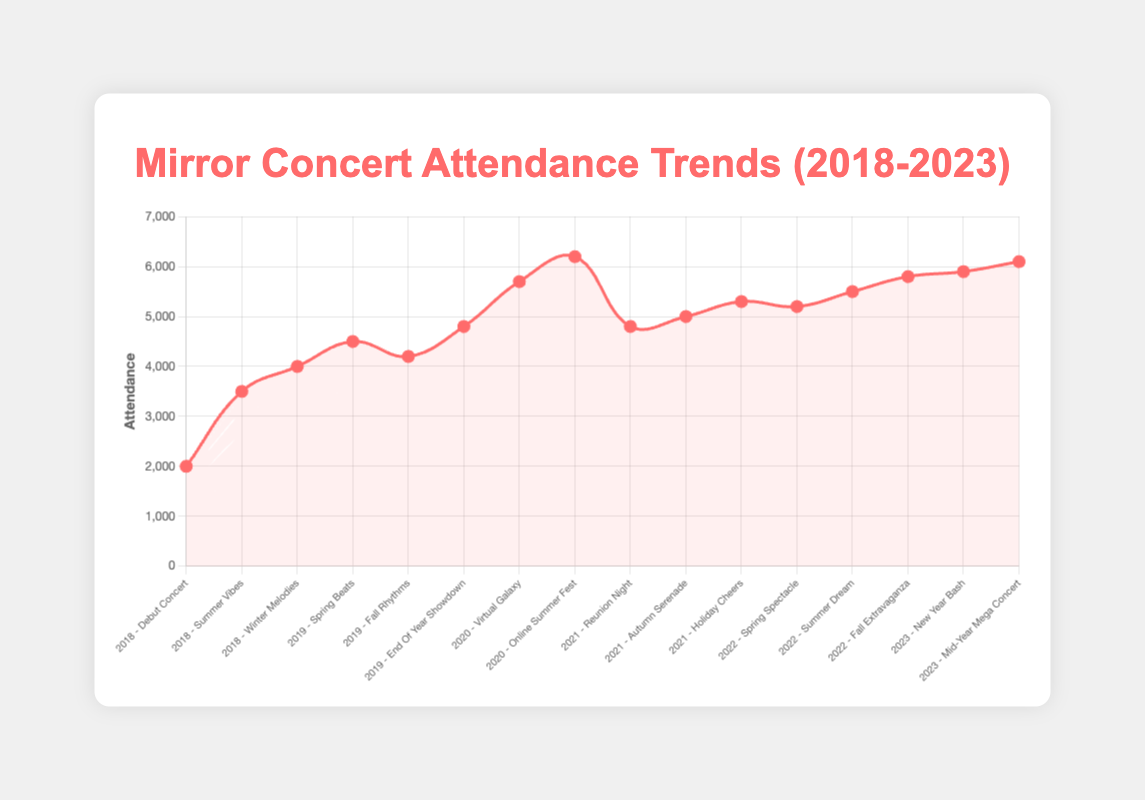What is the overall trend in Mirror's concert attendance from 2018 to 2023? Looking at the line plot, the general trend shows an increase in concert attendance over the years from 2018 to 2023. The attendance started at 2000 in 2018 and reached 6100 by the mid-year concert in 2023.
Answer: Increasing Which concert had the highest attendance over the entire period from 2018 to 2023? The concert with the highest attendance is the "Online Summer Fest" in 2020, with an attendance of 6200. This is evident from the peak point on the plot in the year 2020.
Answer: Online Summer Fest in 2020 How did the attendance of "End Of Year Showdown" in 2019 compare to "Reunion Night" in 2021? "End Of Year Showdown" in 2019 had an attendance of 4800, while "Reunion Night" in 2021 also had an attendance of 4800. Both concerts had the same attendance.
Answer: Equal What is the total concert attendance for the year 2021? The total attendance for 2021 is calculated by summing the attendance of all concerts in that year: 4800 (Reunion Night) + 5000 (Autumn Serenade) + 5300 (Holiday Cheers) = 15100.
Answer: 15100 How much did the attendance increase or decrease from "Debut Concert" in 2018 to "New Year Bash" in 2023? The attendance for "Debut Concert" in 2018 was 2000, and for "New Year Bash" in 2023 was 5900. The increase is calculated as 5900 - 2000 = 3900.
Answer: Increased by 3900 What is the average attendance of all concerts in 2020? The average attendance for 2020 can be calculated by summing the total attendance and dividing by the number of concerts: (5700 + 6200) / 2 = 5950.
Answer: 5950 Compare the attendance of "Spring Beats" in 2019 to "Spring Spectacle" in 2022. Which one had more attendance and by how much? "Spring Beats" in 2019 had an attendance of 4500, while "Spring Spectacle" in 2022 had 5200. The difference is 5200 - 4500 = 700. "Spring Spectacle" had more attendance by 700.
Answer: Spring Spectacle by 700 How did the attendance for "Holiday Cheers" in 2021 visually compare to "Fall Extravaganza" in 2022? Visually, "Holiday Cheers" in 2021 had an attendance of 5300, and "Fall Extravaganza" in 2022 had 5800. The attendance for "Fall Extravaganza" is represented by a higher point on the line plot compared to "Holiday Cheers".
Answer: Fall Extravaganza was higher How many concerts had an attendance higher than 5000 from 2018 to 2023? From the plot, the concerts with attendance higher than 5000 are "Online Summer Fest" (2020), "Autumn Serenade" (2021), "Holiday Cheers" (2021), "Spring Spectacle" (2022), "Summer Dream" (2022), "Fall Extravaganza" (2022), "New Year Bash" (2023), and "Mid-Year Mega Concert" (2023). There are 8 such concerts.
Answer: 8 Which year had the highest total concert attendance, and what was that total? Summing the concert attendance for each year:
2018: 2000 + 3500 + 4000 = 9500
2019: 4500 + 4200 + 4800 = 13500
2020: 5700 + 6200 = 11900
2021: 4800 + 5000 + 5300 = 15100
2022: 5200 + 5500 + 5800 = 16500
2023: 5900 + 6100 = 12000
The highest is 2022 with 16500.
Answer: 2022 with 16500 